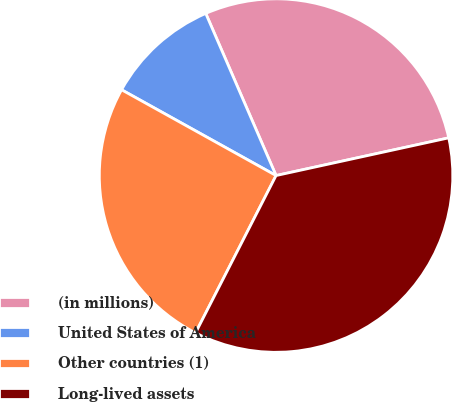<chart> <loc_0><loc_0><loc_500><loc_500><pie_chart><fcel>(in millions)<fcel>United States of America<fcel>Other countries (1)<fcel>Long-lived assets<nl><fcel>28.09%<fcel>10.42%<fcel>25.54%<fcel>35.95%<nl></chart> 